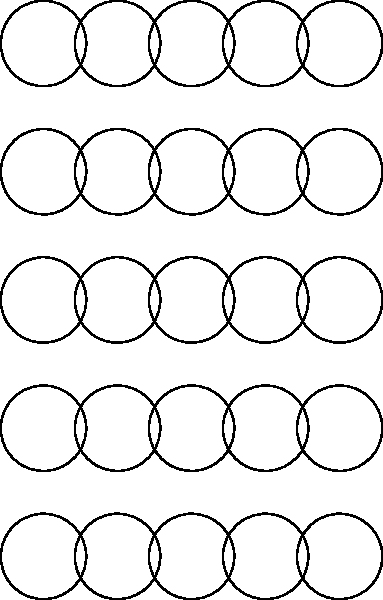In the context of non-Euclidean tessellations for theater backdrop designs, what geometric shape is being used to create the hyperbolic tessellation shown in the image, and how many of these shapes meet at each vertex? To answer this question, let's analyze the image step-by-step:

1. The tessellation is composed of identical curved shapes.
2. Each shape has three curved sides, forming a triangular-like figure.
3. These shapes are known as hyperbolic triangles, which are the non-Euclidean equivalent of triangles in hyperbolic geometry.
4. In a hyperbolic plane, the sum of the angles in a triangle is less than 180°, unlike in Euclidean geometry where it's exactly 180°.
5. Looking at the vertices where these shapes meet, we can count that exactly 7 hyperbolic triangles converge at each point.
6. This 7-triangle vertex arrangement is impossible in Euclidean geometry, demonstrating the non-Euclidean nature of this tessellation.

For theater backdrop designs, such tessellations could create visually striking and mathematically intriguing patterns, offering a unique aesthetic that challenges the audience's perception of space and geometry.
Answer: Hyperbolic triangles; 7 at each vertex 